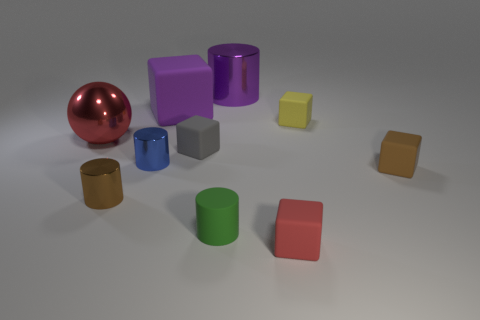What color is the big matte thing that is the same shape as the small yellow thing?
Offer a very short reply. Purple. There is a matte cylinder; is it the same color as the cylinder right of the green thing?
Your answer should be compact. No. The object that is both behind the small yellow matte cube and on the left side of the small gray thing has what shape?
Keep it short and to the point. Cube. Is the number of matte blocks less than the number of brown blocks?
Keep it short and to the point. No. Are there any purple shiny things?
Your answer should be very brief. Yes. What number of other things are the same size as the yellow rubber object?
Keep it short and to the point. 6. Do the big block and the red object in front of the tiny brown block have the same material?
Offer a very short reply. Yes. Are there the same number of yellow matte things that are in front of the green rubber cylinder and large red metal spheres that are on the right side of the red matte thing?
Your response must be concise. Yes. What is the material of the sphere?
Your response must be concise. Metal. The block that is the same size as the sphere is what color?
Offer a terse response. Purple. 